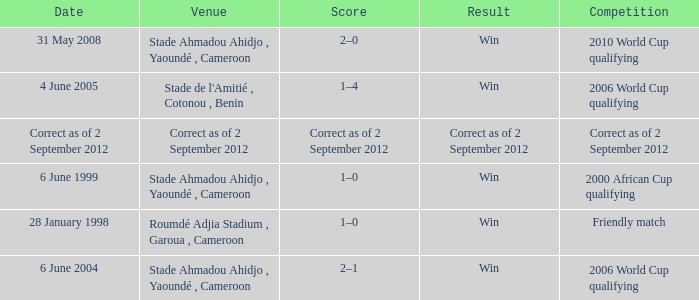What was the result for a friendly match? Win. 